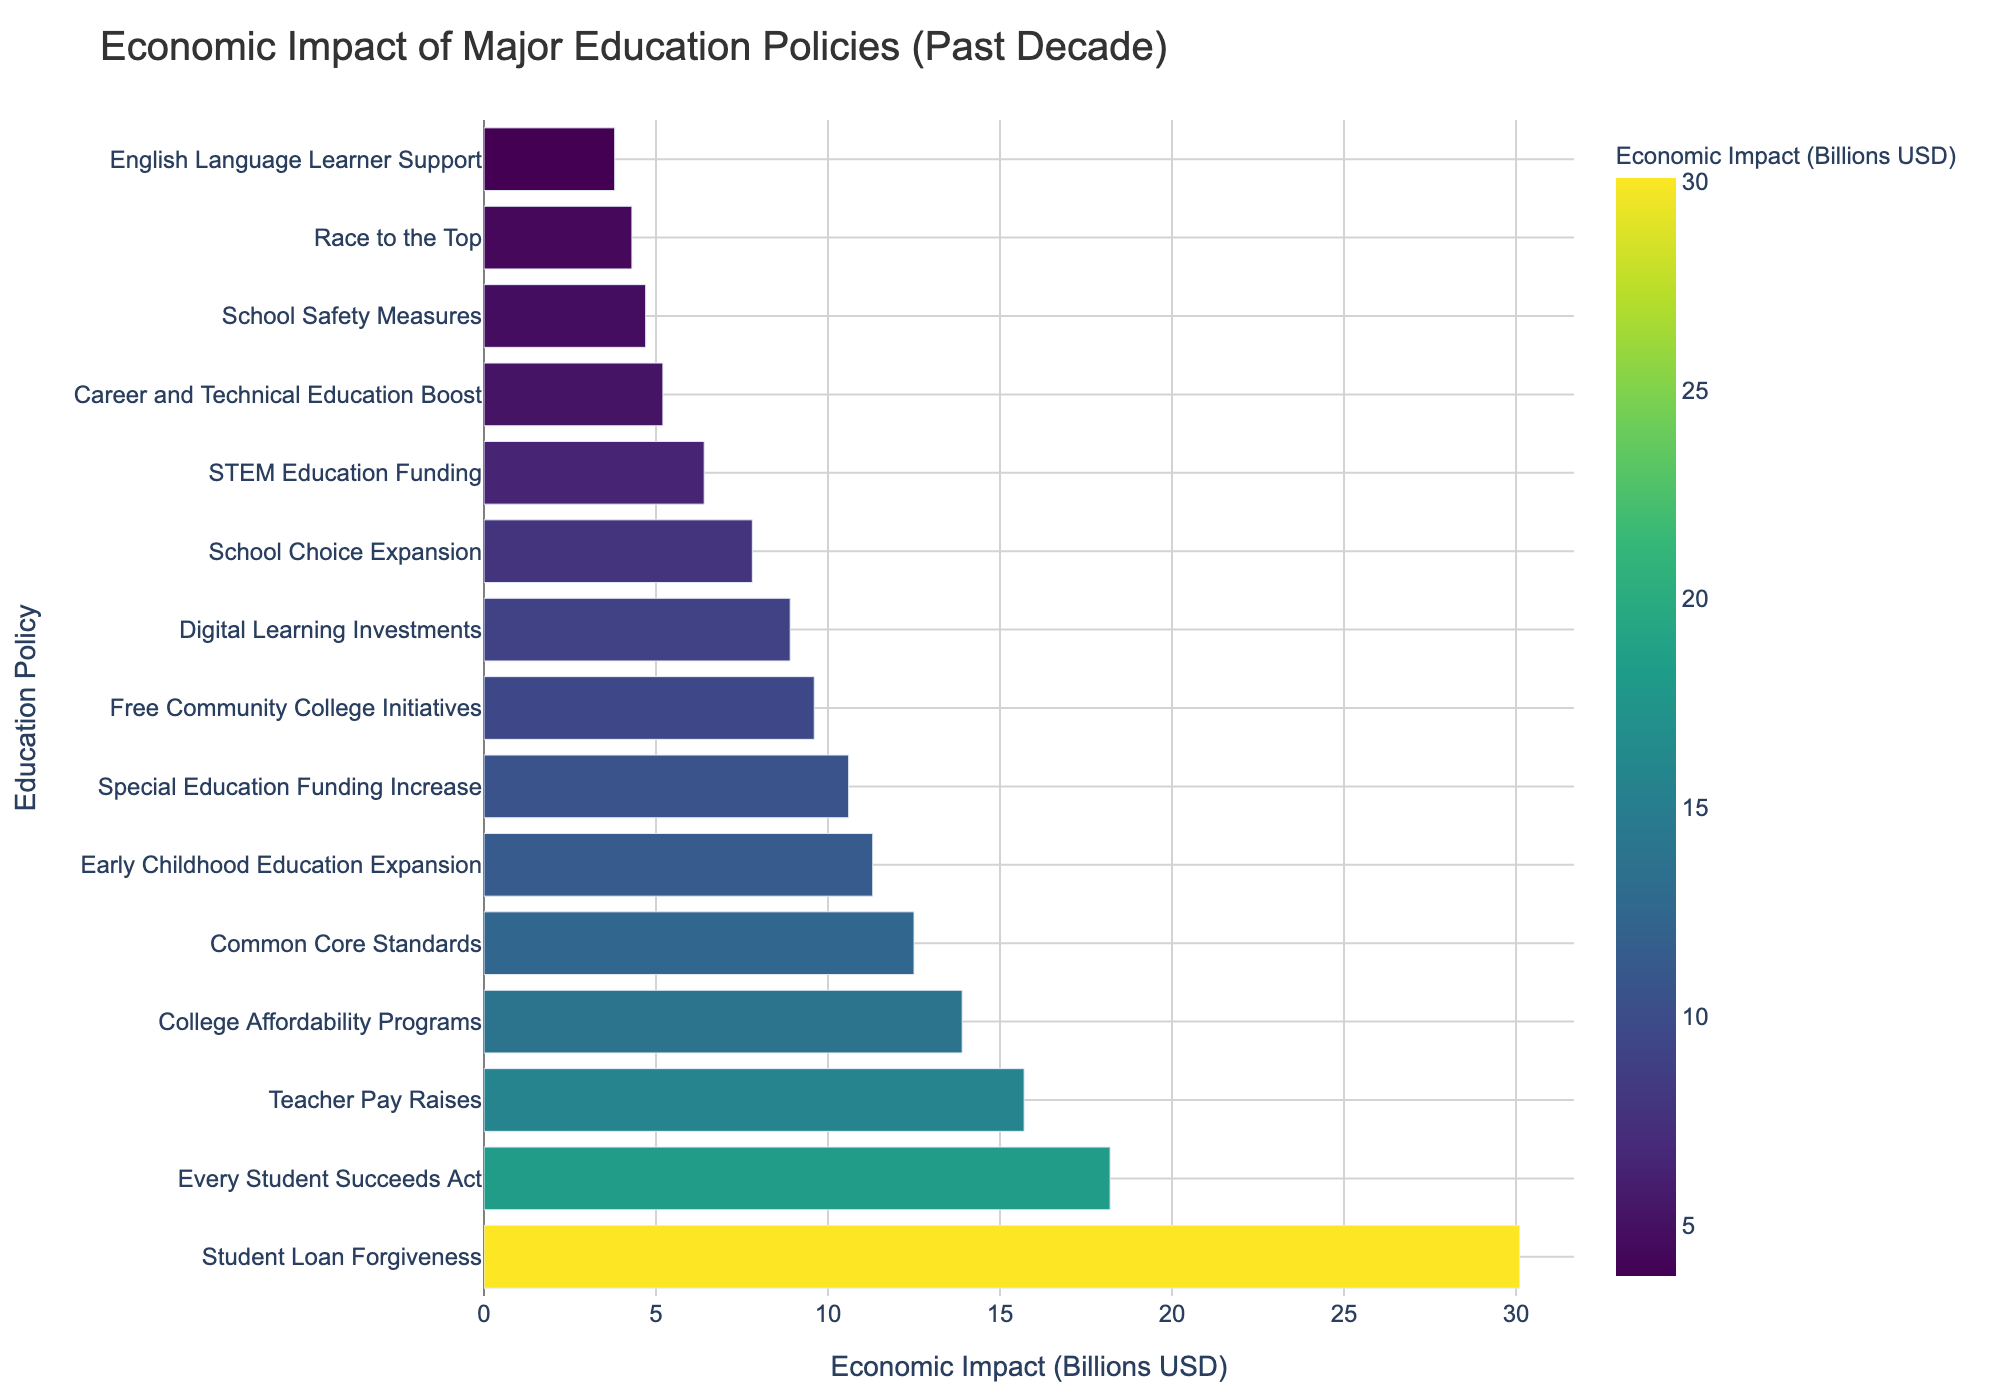Which education policy has the highest economic impact? By observing the length of the bars, the policy with the longest bar corresponds to the highest economic impact. The "Student Loan Forgiveness" policy has the longest bar.
Answer: Student Loan Forgiveness What is the total economic impact of the "Common Core Standards" and "Race to the Top" policies combined? The economic impacts are 12.5 billion USD for "Common Core Standards" and 4.3 billion USD for "Race to the Top". Adding them together yields 12.5 + 4.3 = 16.8 billion USD.
Answer: 16.8 billion USD Which policy has a greater economic impact: "Free Community College Initiatives" or "Teacher Pay Raises"? Comparing the lengths of the bars for these two policies, "Teacher Pay Raises" has a longer bar than "Free Community College Initiatives". Thus, "Teacher Pay Raises" has a greater economic impact.
Answer: Teacher Pay Raises What is the average economic impact of "School Choice Expansion", "STEM Education Funding", and "Early Childhood Education Expansion"? The economic impacts are 7.8, 6.4, and 11.3 billion USD respectively. Summing these gives 7.8 + 6.4 + 11.3 = 25.5 billion USD. The average is then 25.5 / 3 ≈ 8.5 billion USD.
Answer: 8.5 billion USD Which policies have an economic impact less than 5 billion USD? By observing the bars shorter than the value representing 5 billion USD, the policies "Race to the Top", "English Language Learner Support", and "School Safety Measures" have economic impacts less than 5 billion USD.
Answer: Race to the Top, English Language Learner Support, School Safety Measures Among "Digital Learning Investments", "Career and Technical Education Boost", and "College Affordability Programs", which one has the lowest economic impact? Comparing the lengths of the bars for these three policies, "Career and Technical Education Boost" has the shortest bar, indicating the lowest economic impact among them.
Answer: Career and Technical Education Boost How does the economic impact of "Special Education Funding Increase" compare to "Early Childhood Education Expansion"? The bars for these two policies are close in length, but "Special Education Funding Increase" is slightly higher at 10.6 billion USD compared to 11.3 billion USD for "Early Childhood Education Expansion".
Answer: Special Education Funding Increase is higher What is the median economic impact of all the policies listed? To find the median, list all the economic impacts in increasing order: 3.8, 4.3, 4.7, 5.2, 6.4, 7.8, 8.9, 9.6, 10.6, 11.3, 12.5, 13.9, 15.7, 18.2, 30.1. With 15 data points, the median is the 8th value, which is 9.6 billion USD.
Answer: 9.6 billion USD 